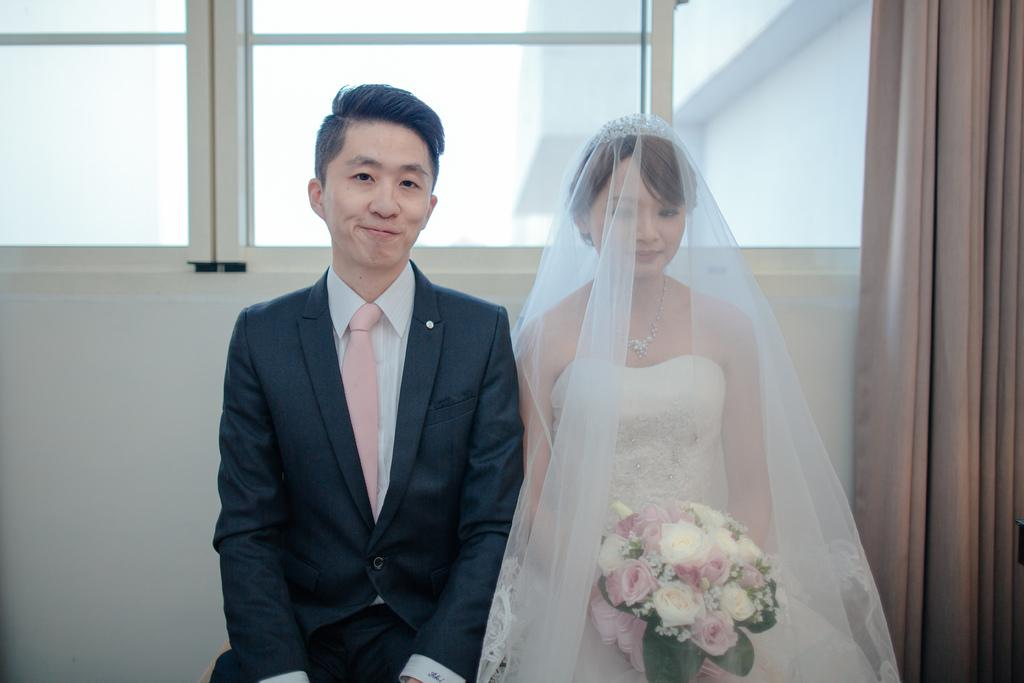How many people are in the image? There are two persons standing in the middle of the image. What are the expressions on their faces? Both persons are smiling. What is one person holding in the image? One person is holding a flower bouquet. What can be seen in the background of the image? There is a wall, windows, and a curtain associated with the windows visible in the background. What type of ground can be seen beneath the persons in the image? There is no ground visible in the image; it appears to be an indoor setting. What reward is the person holding the flower bouquet receiving in the image? There is no indication in the image that the person holding the flower bouquet is receiving a reward. 